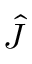Convert formula to latex. <formula><loc_0><loc_0><loc_500><loc_500>\hat { J }</formula> 